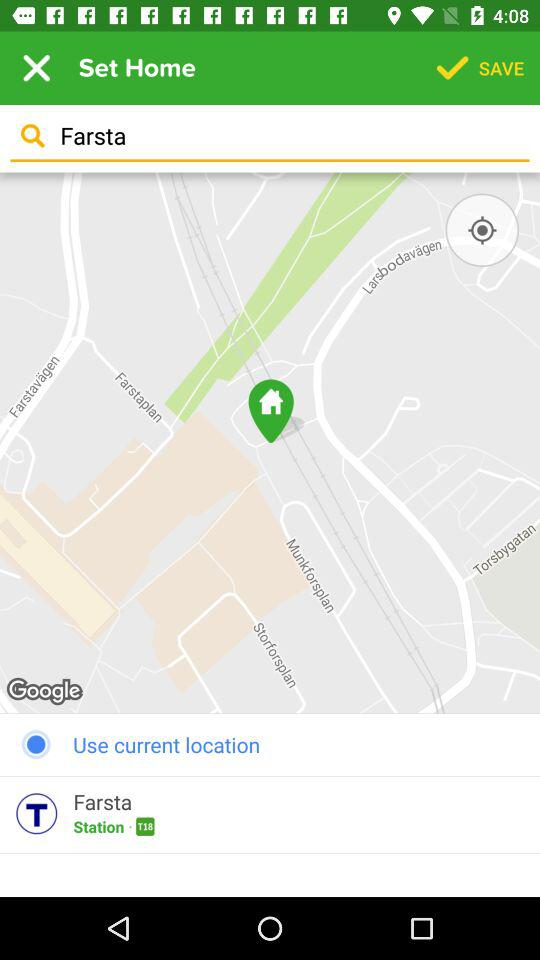What's the station number? The station number is T18. 